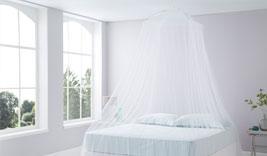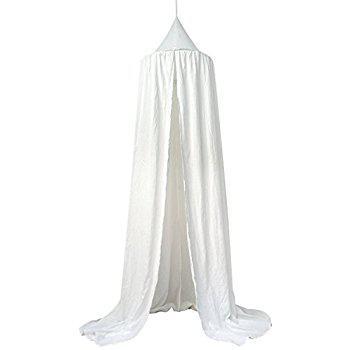The first image is the image on the left, the second image is the image on the right. Given the left and right images, does the statement "Each image shows a gauzy white canopy that drapes from a cone shape suspended from the ceiling, but only the left image shows a canopy over a bed." hold true? Answer yes or no. Yes. The first image is the image on the left, the second image is the image on the right. For the images displayed, is the sentence "There is at least one window behind the canopy in one of the images" factually correct? Answer yes or no. Yes. 